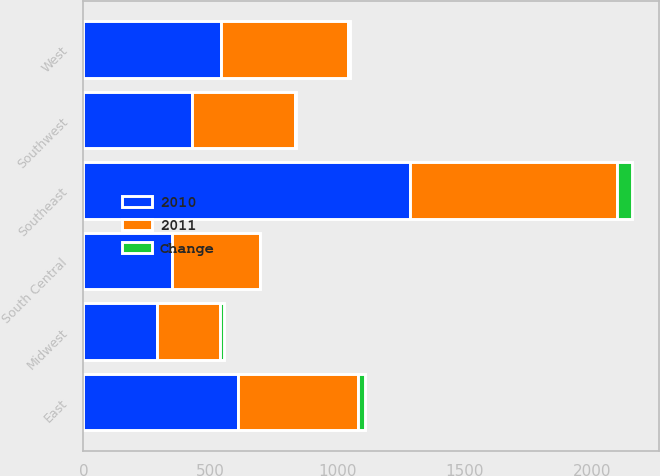Convert chart. <chart><loc_0><loc_0><loc_500><loc_500><stacked_bar_chart><ecel><fcel>East<fcel>Midwest<fcel>Southeast<fcel>South Central<fcel>Southwest<fcel>West<nl><fcel>2010<fcel>606<fcel>288<fcel>1285<fcel>346.5<fcel>426<fcel>539<nl><fcel>2011<fcel>472<fcel>247<fcel>812<fcel>346.5<fcel>405<fcel>501<nl><fcel>Change<fcel>28<fcel>17<fcel>58<fcel>1<fcel>5<fcel>8<nl></chart> 